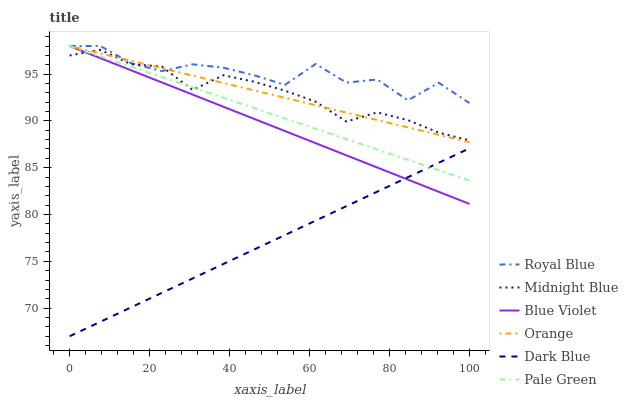Does Dark Blue have the minimum area under the curve?
Answer yes or no. Yes. Does Royal Blue have the maximum area under the curve?
Answer yes or no. Yes. Does Royal Blue have the minimum area under the curve?
Answer yes or no. No. Does Dark Blue have the maximum area under the curve?
Answer yes or no. No. Is Pale Green the smoothest?
Answer yes or no. Yes. Is Royal Blue the roughest?
Answer yes or no. Yes. Is Dark Blue the smoothest?
Answer yes or no. No. Is Dark Blue the roughest?
Answer yes or no. No. Does Royal Blue have the lowest value?
Answer yes or no. No. Does Dark Blue have the highest value?
Answer yes or no. No. Is Dark Blue less than Royal Blue?
Answer yes or no. Yes. Is Midnight Blue greater than Dark Blue?
Answer yes or no. Yes. Does Dark Blue intersect Royal Blue?
Answer yes or no. No. 